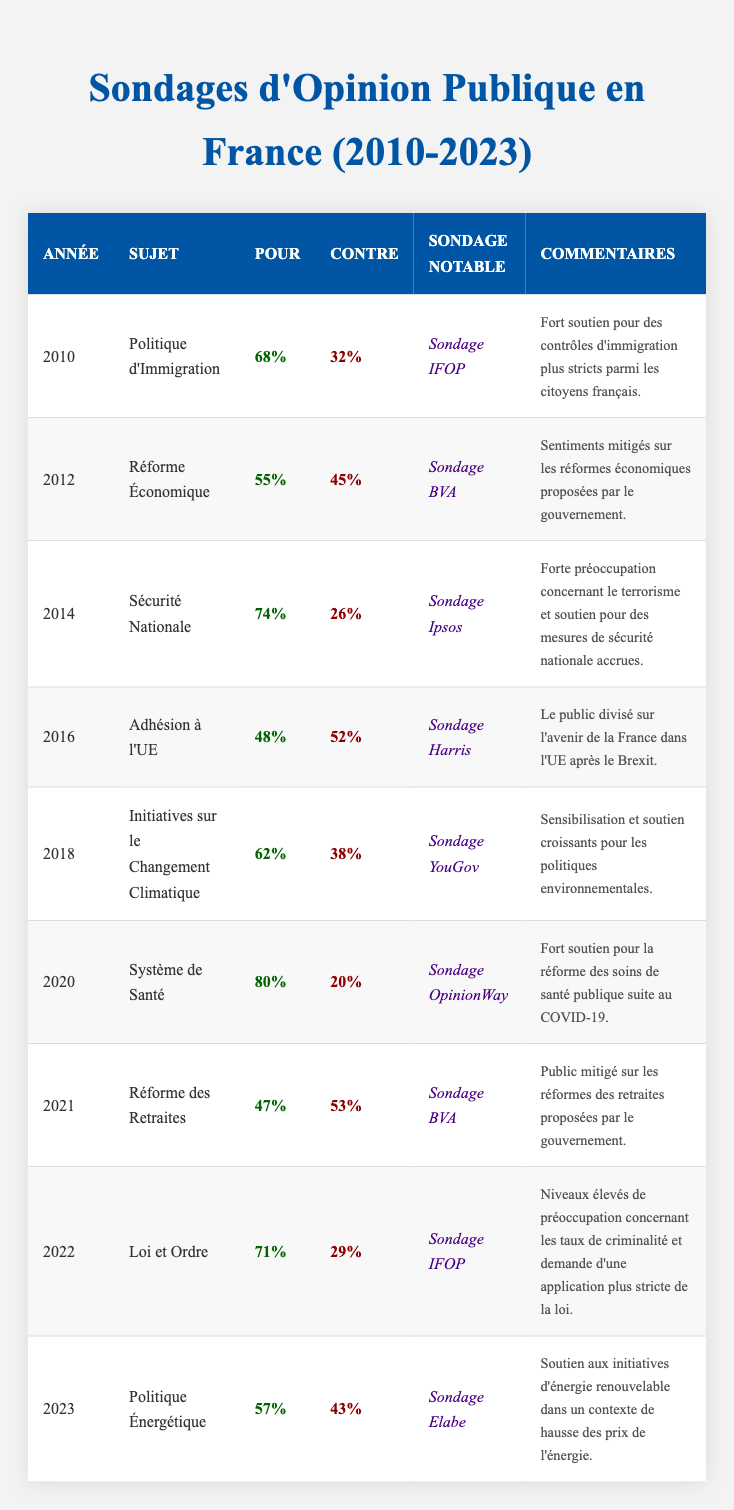What was the support percentage for immigration policy in 2010? Referring to the table, the support percentage for immigration policy in 2010 is found in the corresponding row, which shows 68%.
Answer: 68% What issue had the highest support percentage according to the table? By examining the support percentages listed in the table, the issue with the highest support is national security in 2014, with a percentage of 74%.
Answer: 74% In which year was the support for pension reform lower than opposition? The table shows that in 2021, support for pension reform was 47%, while opposition was 53%, indicating that support was lower.
Answer: 2021 What is the average support percentage for the years 2010, 2012, and 2014? We take the support percentages for these years: 68, 55, and 74. The sum is 68 + 55 + 74 = 197. Dividing by the number of years (3) gives 197/3 = approximately 65.67.
Answer: 65.67 How many issues had greater than 60% support during the surveyed years? Looking at the support percentages greater than 60% in the table, we find: Immigration Policy (68%), National Security (74%), Climate Change Initiatives (62%), and Health Care System (80%). This counts up to 4 issues.
Answer: 4 Was there more support or opposition for energy policy in 2023? Analyzing the 2023 row, support for energy policy was 57%, while opposition was 43%. Since 57% is greater than 43%, there was more support.
Answer: More support Which issue shown in the table had the most mixed feelings from the public? In 2021, pension reform had the closest percentages of support (47%) and opposition (53%), reflecting the most mixed feelings among the public.
Answer: Pension Reform What was the change in support percentage for law and order from 2021 to 2022? The support for law and order in 2022 was 71%, while in 2021 it was 47%. The change is 71 - 47 = 24 percentage points increase.
Answer: 24 percentage points Was support for health care system reform higher than for climate change initiatives? In the table, health care system support is 80% and climate change initiatives support is 62%. Since 80% is greater than 62%, health care system reform had higher support.
Answer: Yes What percentage of respondents opposed economic reform in 2012? Referring to the 2012 row in the table, opposition to economic reform was 45%.
Answer: 45% How did support for energy policy in 2023 compare to support for immigration policy in 2010? Energy policy support in 2023 was 57%, while immigration policy support in 2010 was 68%. Since 57% is less than 68%, support for energy policy was lower.
Answer: Lower 